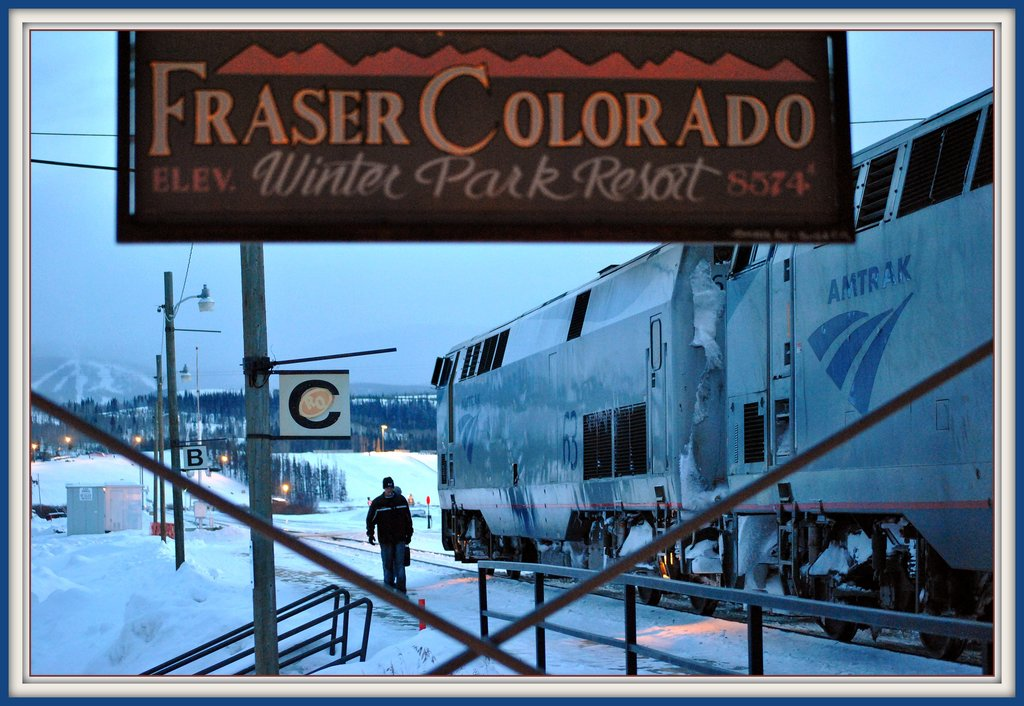What do you think is the significance of trains in this region based on the image? Trains, as depicted in the image, are likely a vital link for residents and tourists in Fraser, Colorado, especially given the rugged, mountainous terrain and the heavy snowfall evident. This mode of transportation provides essential connectivity to wider regions and is crucial for both functional travel and tourism, particularly to access destinations like the nearby Winter Park Resort. The train's robust presence against the harsh winter backdrop underscores its reliability and importance in overcoming geographical and climatic challenges. 